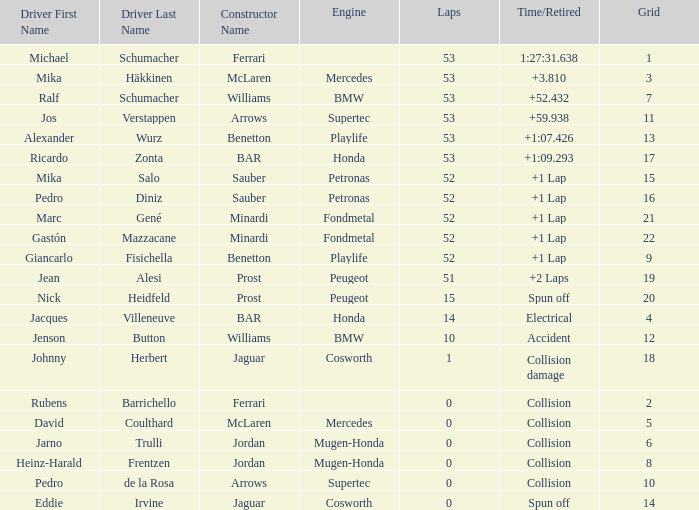Could you help me parse every detail presented in this table? {'header': ['Driver First Name', 'Driver Last Name', 'Constructor Name', 'Engine', 'Laps', 'Time/Retired', 'Grid'], 'rows': [['Michael', 'Schumacher', 'Ferrari', '', '53', '1:27:31.638', '1'], ['Mika', 'Häkkinen', 'McLaren', 'Mercedes', '53', '+3.810', '3'], ['Ralf', 'Schumacher', 'Williams', 'BMW', '53', '+52.432', '7'], ['Jos', 'Verstappen', 'Arrows', 'Supertec', '53', '+59.938', '11'], ['Alexander', 'Wurz', 'Benetton', 'Playlife', '53', '+1:07.426', '13'], ['Ricardo', 'Zonta', 'BAR', 'Honda', '53', '+1:09.293', '17'], ['Mika', 'Salo', 'Sauber', 'Petronas', '52', '+1 Lap', '15'], ['Pedro', 'Diniz', 'Sauber', 'Petronas', '52', '+1 Lap', '16'], ['Marc', 'Gené', 'Minardi', 'Fondmetal', '52', '+1 Lap', '21'], ['Gastón', 'Mazzacane', 'Minardi', 'Fondmetal', '52', '+1 Lap', '22'], ['Giancarlo', 'Fisichella', 'Benetton', 'Playlife', '52', '+1 Lap', '9'], ['Jean', 'Alesi', 'Prost', 'Peugeot', '51', '+2 Laps', '19'], ['Nick', 'Heidfeld', 'Prost', 'Peugeot', '15', 'Spun off', '20'], ['Jacques', 'Villeneuve', 'BAR', 'Honda', '14', 'Electrical', '4'], ['Jenson', 'Button', 'Williams', 'BMW', '10', 'Accident', '12'], ['Johnny', 'Herbert', 'Jaguar', 'Cosworth', '1', 'Collision damage', '18'], ['Rubens', 'Barrichello', 'Ferrari', '', '0', 'Collision', '2'], ['David', 'Coulthard', 'McLaren', 'Mercedes', '0', 'Collision', '5'], ['Jarno', 'Trulli', 'Jordan', 'Mugen-Honda', '0', 'Collision', '6'], ['Heinz-Harald', 'Frentzen', 'Jordan', 'Mugen-Honda', '0', 'Collision', '8'], ['Pedro', 'de la Rosa', 'Arrows', 'Supertec', '0', 'Collision', '10'], ['Eddie', 'Irvine', 'Jaguar', 'Cosworth', '0', 'Spun off', '14']]} How many laps did Ricardo Zonta have? 53.0. 